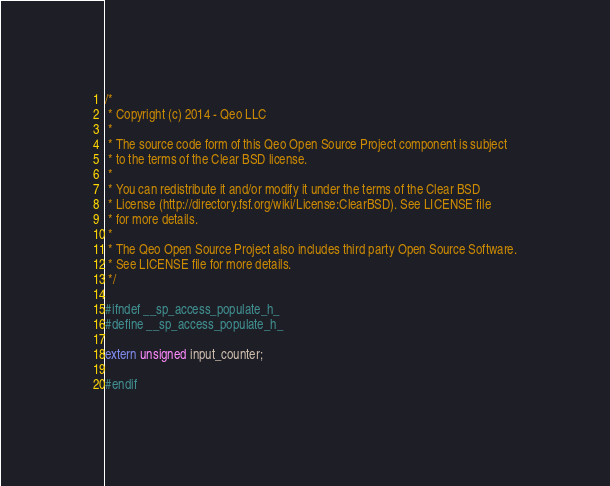Convert code to text. <code><loc_0><loc_0><loc_500><loc_500><_C_>/*
 * Copyright (c) 2014 - Qeo LLC
 *
 * The source code form of this Qeo Open Source Project component is subject
 * to the terms of the Clear BSD license.
 *
 * You can redistribute it and/or modify it under the terms of the Clear BSD
 * License (http://directory.fsf.org/wiki/License:ClearBSD). See LICENSE file
 * for more details.
 *
 * The Qeo Open Source Project also includes third party Open Source Software.
 * See LICENSE file for more details.
 */

#ifndef __sp_access_populate_h_
#define __sp_access_populate_h_

extern unsigned input_counter;

#endif
</code> 